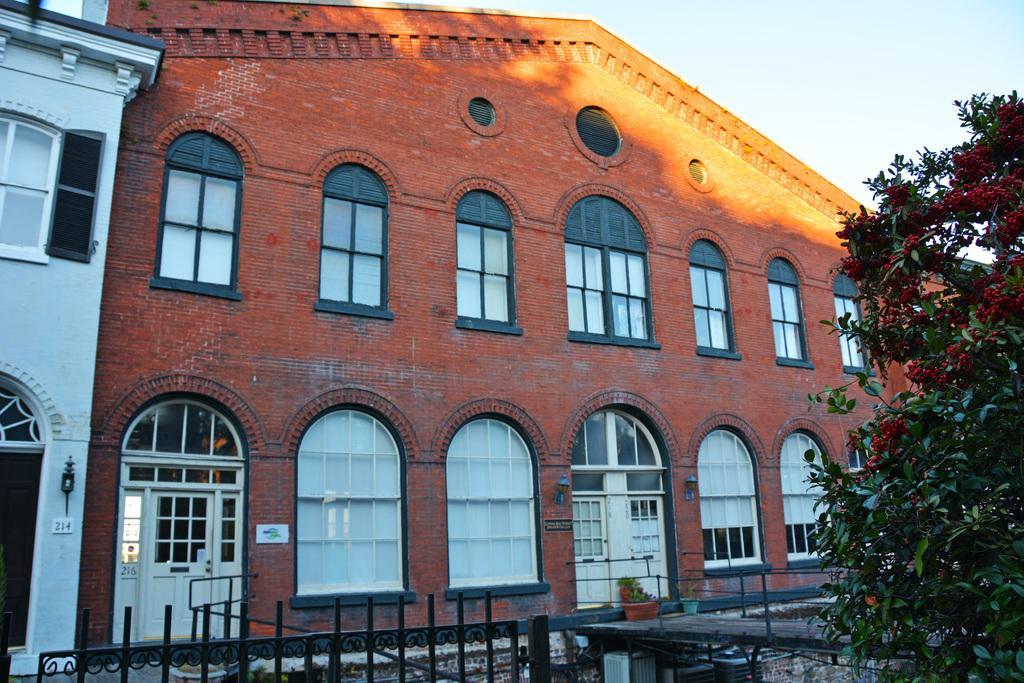In one or two sentences, can you explain what this image depicts? There is a fencing at the bottom of this image and there is a tree on the right side of this image. There are some buildings in the background. There is a sky at the top of this image. 